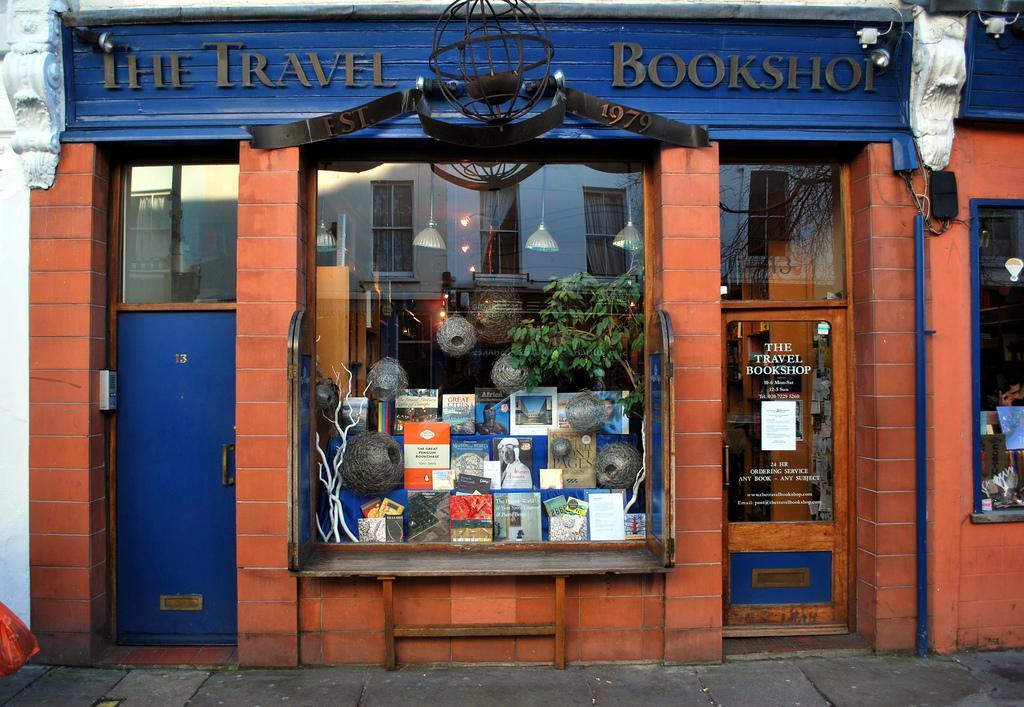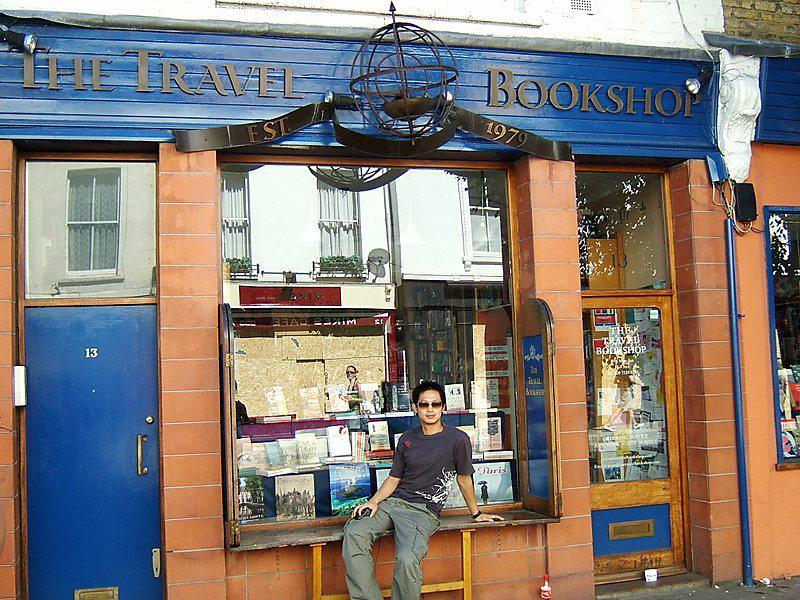The first image is the image on the left, the second image is the image on the right. For the images displayed, is the sentence "There is a person sitting down on the ledge along the storefront window." factually correct? Answer yes or no. Yes. The first image is the image on the left, the second image is the image on the right. Considering the images on both sides, is "Two images of the same brick bookshop with blue trim show a large window between two doorways, a person sitting on a window ledge in one image." valid? Answer yes or no. Yes. 